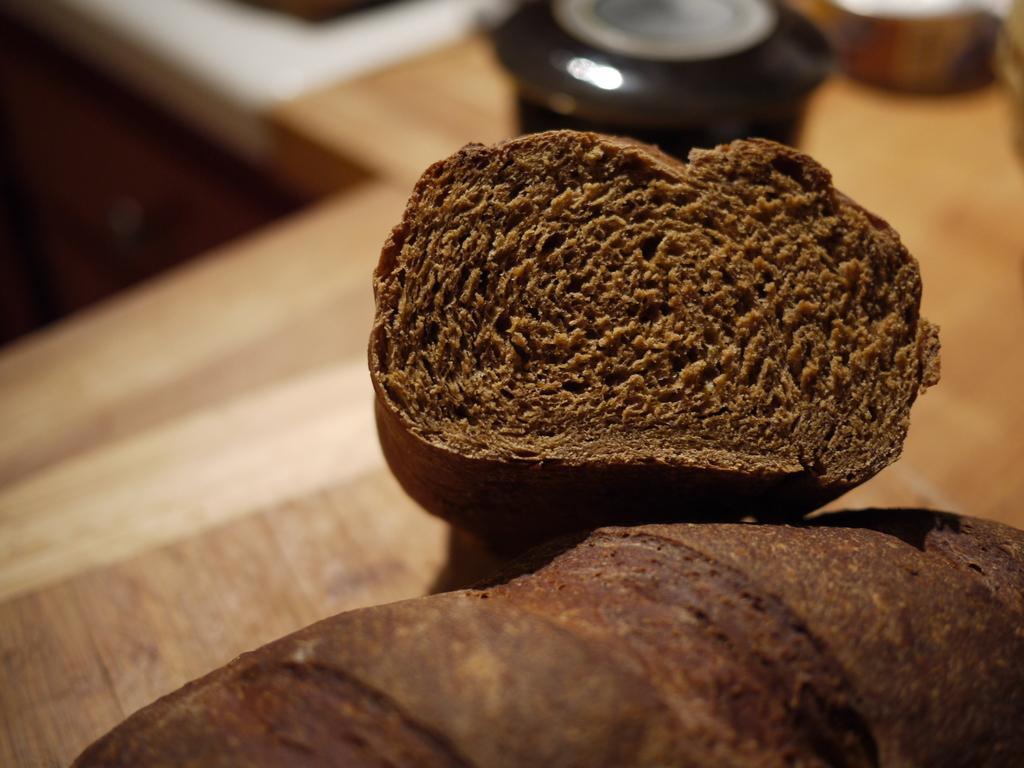Describe this image in one or two sentences. In this image we can see some food item which is in brown color and in the background of the image there are some utensils on the surface. 